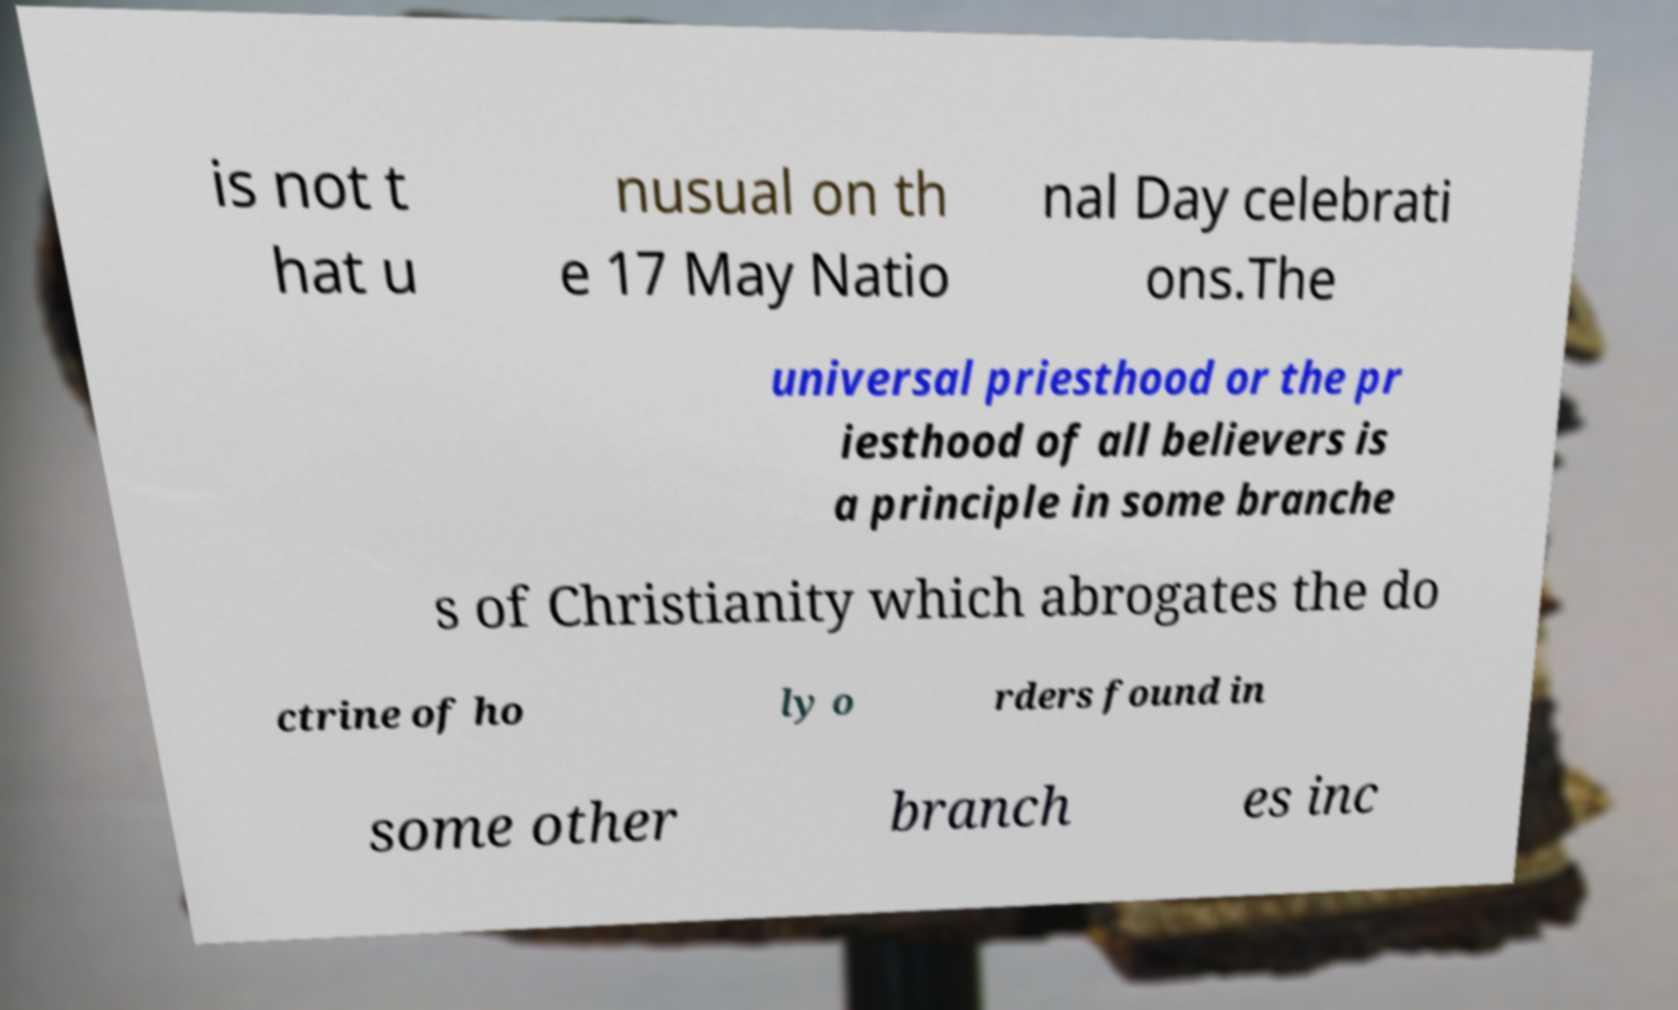Please identify and transcribe the text found in this image. is not t hat u nusual on th e 17 May Natio nal Day celebrati ons.The universal priesthood or the pr iesthood of all believers is a principle in some branche s of Christianity which abrogates the do ctrine of ho ly o rders found in some other branch es inc 